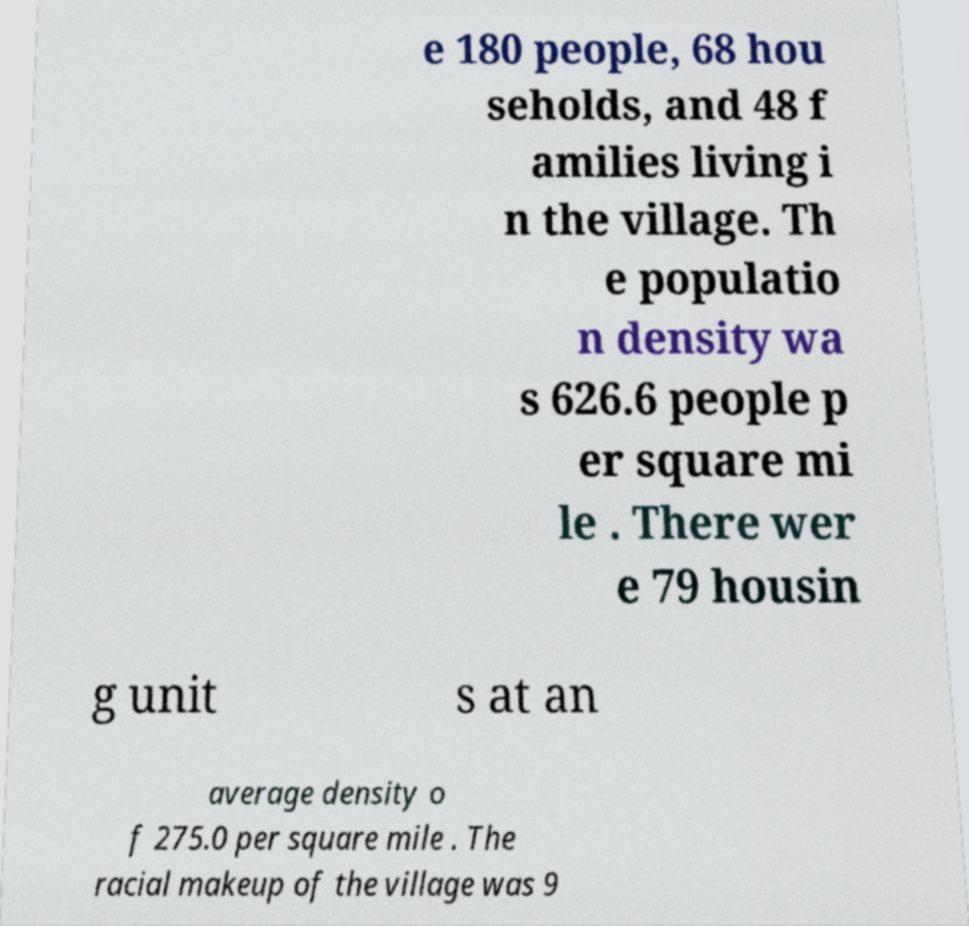Please read and relay the text visible in this image. What does it say? e 180 people, 68 hou seholds, and 48 f amilies living i n the village. Th e populatio n density wa s 626.6 people p er square mi le . There wer e 79 housin g unit s at an average density o f 275.0 per square mile . The racial makeup of the village was 9 